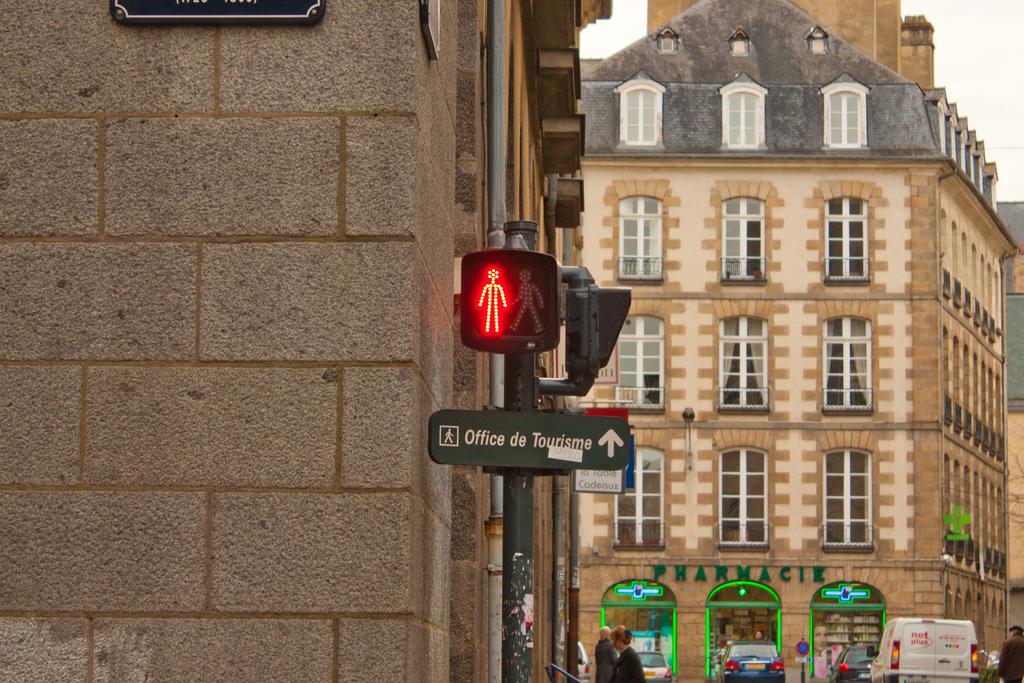What is the sign giving directions to?
Ensure brevity in your answer.  Office de tourisme. What do the green letters say?
Offer a terse response. Pharmacie. 